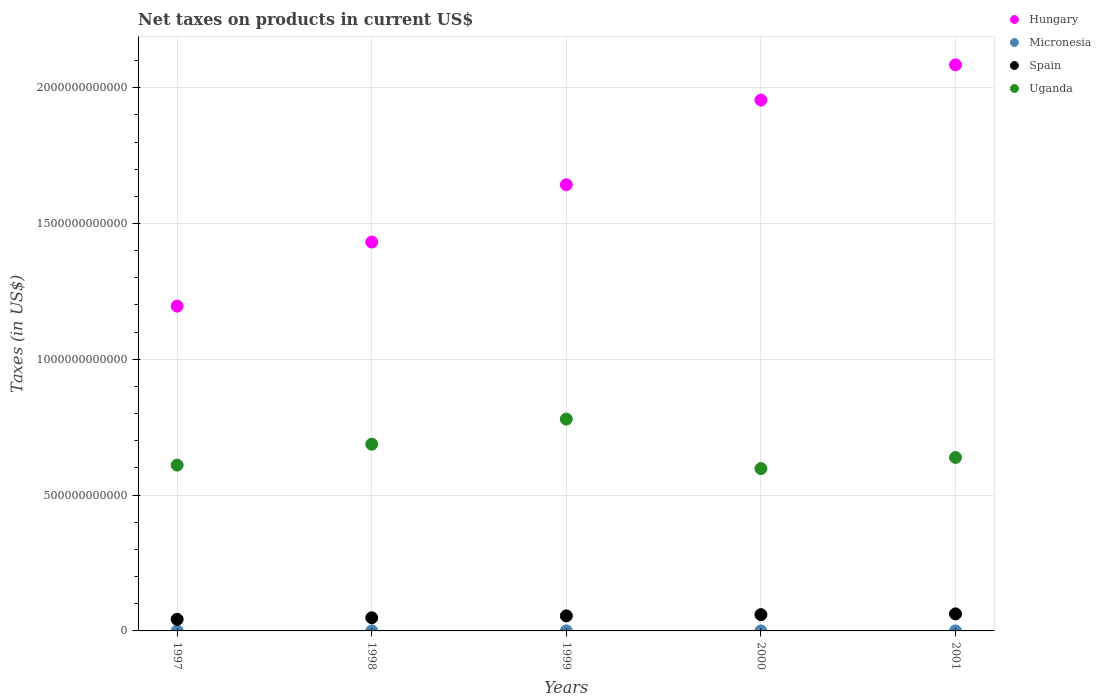How many different coloured dotlines are there?
Offer a very short reply. 4. What is the net taxes on products in Uganda in 1997?
Ensure brevity in your answer.  6.11e+11. Across all years, what is the maximum net taxes on products in Hungary?
Make the answer very short. 2.08e+12. Across all years, what is the minimum net taxes on products in Spain?
Keep it short and to the point. 4.27e+1. What is the total net taxes on products in Spain in the graph?
Give a very brief answer. 2.69e+11. What is the difference between the net taxes on products in Hungary in 1997 and that in 1999?
Keep it short and to the point. -4.47e+11. What is the difference between the net taxes on products in Uganda in 1997 and the net taxes on products in Spain in 2001?
Give a very brief answer. 5.48e+11. What is the average net taxes on products in Spain per year?
Give a very brief answer. 5.38e+1. In the year 1998, what is the difference between the net taxes on products in Uganda and net taxes on products in Spain?
Offer a very short reply. 6.39e+11. What is the ratio of the net taxes on products in Hungary in 1999 to that in 2000?
Make the answer very short. 0.84. Is the net taxes on products in Hungary in 1997 less than that in 1998?
Offer a very short reply. Yes. What is the difference between the highest and the second highest net taxes on products in Uganda?
Provide a succinct answer. 9.24e+1. What is the difference between the highest and the lowest net taxes on products in Micronesia?
Provide a succinct answer. 4.64e+06. Is it the case that in every year, the sum of the net taxes on products in Spain and net taxes on products in Micronesia  is greater than the net taxes on products in Hungary?
Offer a very short reply. No. Is the net taxes on products in Uganda strictly less than the net taxes on products in Hungary over the years?
Provide a succinct answer. Yes. How many dotlines are there?
Your answer should be compact. 4. What is the difference between two consecutive major ticks on the Y-axis?
Offer a very short reply. 5.00e+11. Does the graph contain grids?
Offer a very short reply. Yes. How many legend labels are there?
Your answer should be very brief. 4. What is the title of the graph?
Offer a very short reply. Net taxes on products in current US$. Does "Bulgaria" appear as one of the legend labels in the graph?
Make the answer very short. No. What is the label or title of the X-axis?
Ensure brevity in your answer.  Years. What is the label or title of the Y-axis?
Your response must be concise. Taxes (in US$). What is the Taxes (in US$) of Hungary in 1997?
Offer a terse response. 1.20e+12. What is the Taxes (in US$) of Micronesia in 1997?
Offer a terse response. 1.00e+07. What is the Taxes (in US$) in Spain in 1997?
Make the answer very short. 4.27e+1. What is the Taxes (in US$) in Uganda in 1997?
Your response must be concise. 6.11e+11. What is the Taxes (in US$) in Hungary in 1998?
Provide a succinct answer. 1.43e+12. What is the Taxes (in US$) in Micronesia in 1998?
Your response must be concise. 1.18e+07. What is the Taxes (in US$) of Spain in 1998?
Give a very brief answer. 4.85e+1. What is the Taxes (in US$) in Uganda in 1998?
Provide a succinct answer. 6.87e+11. What is the Taxes (in US$) in Hungary in 1999?
Give a very brief answer. 1.64e+12. What is the Taxes (in US$) of Micronesia in 1999?
Your response must be concise. 1.37e+07. What is the Taxes (in US$) in Spain in 1999?
Ensure brevity in your answer.  5.54e+1. What is the Taxes (in US$) in Uganda in 1999?
Give a very brief answer. 7.80e+11. What is the Taxes (in US$) of Hungary in 2000?
Give a very brief answer. 1.95e+12. What is the Taxes (in US$) in Micronesia in 2000?
Your response must be concise. 1.47e+07. What is the Taxes (in US$) in Spain in 2000?
Provide a succinct answer. 5.99e+1. What is the Taxes (in US$) in Uganda in 2000?
Give a very brief answer. 5.98e+11. What is the Taxes (in US$) in Hungary in 2001?
Offer a very short reply. 2.08e+12. What is the Taxes (in US$) of Micronesia in 2001?
Make the answer very short. 1.35e+07. What is the Taxes (in US$) of Spain in 2001?
Provide a succinct answer. 6.27e+1. What is the Taxes (in US$) of Uganda in 2001?
Your answer should be very brief. 6.39e+11. Across all years, what is the maximum Taxes (in US$) in Hungary?
Provide a short and direct response. 2.08e+12. Across all years, what is the maximum Taxes (in US$) in Micronesia?
Give a very brief answer. 1.47e+07. Across all years, what is the maximum Taxes (in US$) in Spain?
Offer a very short reply. 6.27e+1. Across all years, what is the maximum Taxes (in US$) in Uganda?
Your response must be concise. 7.80e+11. Across all years, what is the minimum Taxes (in US$) in Hungary?
Provide a short and direct response. 1.20e+12. Across all years, what is the minimum Taxes (in US$) of Micronesia?
Make the answer very short. 1.00e+07. Across all years, what is the minimum Taxes (in US$) of Spain?
Give a very brief answer. 4.27e+1. Across all years, what is the minimum Taxes (in US$) of Uganda?
Your response must be concise. 5.98e+11. What is the total Taxes (in US$) in Hungary in the graph?
Keep it short and to the point. 8.31e+12. What is the total Taxes (in US$) of Micronesia in the graph?
Offer a very short reply. 6.37e+07. What is the total Taxes (in US$) in Spain in the graph?
Provide a short and direct response. 2.69e+11. What is the total Taxes (in US$) of Uganda in the graph?
Give a very brief answer. 3.31e+12. What is the difference between the Taxes (in US$) in Hungary in 1997 and that in 1998?
Give a very brief answer. -2.36e+11. What is the difference between the Taxes (in US$) of Micronesia in 1997 and that in 1998?
Keep it short and to the point. -1.83e+06. What is the difference between the Taxes (in US$) in Spain in 1997 and that in 1998?
Your answer should be very brief. -5.72e+09. What is the difference between the Taxes (in US$) of Uganda in 1997 and that in 1998?
Offer a very short reply. -7.69e+1. What is the difference between the Taxes (in US$) in Hungary in 1997 and that in 1999?
Your answer should be compact. -4.47e+11. What is the difference between the Taxes (in US$) of Micronesia in 1997 and that in 1999?
Your answer should be very brief. -3.65e+06. What is the difference between the Taxes (in US$) of Spain in 1997 and that in 1999?
Provide a short and direct response. -1.26e+1. What is the difference between the Taxes (in US$) of Uganda in 1997 and that in 1999?
Your response must be concise. -1.69e+11. What is the difference between the Taxes (in US$) in Hungary in 1997 and that in 2000?
Offer a terse response. -7.58e+11. What is the difference between the Taxes (in US$) in Micronesia in 1997 and that in 2000?
Provide a short and direct response. -4.64e+06. What is the difference between the Taxes (in US$) in Spain in 1997 and that in 2000?
Make the answer very short. -1.72e+1. What is the difference between the Taxes (in US$) in Uganda in 1997 and that in 2000?
Your answer should be very brief. 1.29e+1. What is the difference between the Taxes (in US$) in Hungary in 1997 and that in 2001?
Provide a short and direct response. -8.88e+11. What is the difference between the Taxes (in US$) of Micronesia in 1997 and that in 2001?
Offer a terse response. -3.47e+06. What is the difference between the Taxes (in US$) of Spain in 1997 and that in 2001?
Provide a short and direct response. -2.00e+1. What is the difference between the Taxes (in US$) of Uganda in 1997 and that in 2001?
Offer a terse response. -2.80e+1. What is the difference between the Taxes (in US$) in Hungary in 1998 and that in 1999?
Your answer should be very brief. -2.11e+11. What is the difference between the Taxes (in US$) in Micronesia in 1998 and that in 1999?
Your answer should be compact. -1.82e+06. What is the difference between the Taxes (in US$) in Spain in 1998 and that in 1999?
Your answer should be compact. -6.91e+09. What is the difference between the Taxes (in US$) of Uganda in 1998 and that in 1999?
Provide a short and direct response. -9.24e+1. What is the difference between the Taxes (in US$) of Hungary in 1998 and that in 2000?
Provide a short and direct response. -5.22e+11. What is the difference between the Taxes (in US$) in Micronesia in 1998 and that in 2000?
Keep it short and to the point. -2.81e+06. What is the difference between the Taxes (in US$) of Spain in 1998 and that in 2000?
Provide a short and direct response. -1.15e+1. What is the difference between the Taxes (in US$) in Uganda in 1998 and that in 2000?
Your answer should be compact. 8.98e+1. What is the difference between the Taxes (in US$) of Hungary in 1998 and that in 2001?
Your answer should be compact. -6.52e+11. What is the difference between the Taxes (in US$) in Micronesia in 1998 and that in 2001?
Make the answer very short. -1.64e+06. What is the difference between the Taxes (in US$) in Spain in 1998 and that in 2001?
Ensure brevity in your answer.  -1.42e+1. What is the difference between the Taxes (in US$) in Uganda in 1998 and that in 2001?
Provide a succinct answer. 4.89e+1. What is the difference between the Taxes (in US$) of Hungary in 1999 and that in 2000?
Provide a succinct answer. -3.12e+11. What is the difference between the Taxes (in US$) of Micronesia in 1999 and that in 2000?
Offer a terse response. -9.94e+05. What is the difference between the Taxes (in US$) of Spain in 1999 and that in 2000?
Provide a short and direct response. -4.55e+09. What is the difference between the Taxes (in US$) of Uganda in 1999 and that in 2000?
Your response must be concise. 1.82e+11. What is the difference between the Taxes (in US$) in Hungary in 1999 and that in 2001?
Your response must be concise. -4.41e+11. What is the difference between the Taxes (in US$) in Micronesia in 1999 and that in 2001?
Your response must be concise. 1.83e+05. What is the difference between the Taxes (in US$) of Spain in 1999 and that in 2001?
Your answer should be compact. -7.33e+09. What is the difference between the Taxes (in US$) of Uganda in 1999 and that in 2001?
Offer a very short reply. 1.41e+11. What is the difference between the Taxes (in US$) of Hungary in 2000 and that in 2001?
Ensure brevity in your answer.  -1.30e+11. What is the difference between the Taxes (in US$) of Micronesia in 2000 and that in 2001?
Make the answer very short. 1.18e+06. What is the difference between the Taxes (in US$) of Spain in 2000 and that in 2001?
Your answer should be compact. -2.78e+09. What is the difference between the Taxes (in US$) of Uganda in 2000 and that in 2001?
Provide a short and direct response. -4.09e+1. What is the difference between the Taxes (in US$) of Hungary in 1997 and the Taxes (in US$) of Micronesia in 1998?
Make the answer very short. 1.20e+12. What is the difference between the Taxes (in US$) in Hungary in 1997 and the Taxes (in US$) in Spain in 1998?
Your response must be concise. 1.15e+12. What is the difference between the Taxes (in US$) of Hungary in 1997 and the Taxes (in US$) of Uganda in 1998?
Provide a succinct answer. 5.08e+11. What is the difference between the Taxes (in US$) of Micronesia in 1997 and the Taxes (in US$) of Spain in 1998?
Your answer should be compact. -4.85e+1. What is the difference between the Taxes (in US$) in Micronesia in 1997 and the Taxes (in US$) in Uganda in 1998?
Keep it short and to the point. -6.87e+11. What is the difference between the Taxes (in US$) in Spain in 1997 and the Taxes (in US$) in Uganda in 1998?
Offer a very short reply. -6.45e+11. What is the difference between the Taxes (in US$) in Hungary in 1997 and the Taxes (in US$) in Micronesia in 1999?
Your answer should be compact. 1.20e+12. What is the difference between the Taxes (in US$) of Hungary in 1997 and the Taxes (in US$) of Spain in 1999?
Keep it short and to the point. 1.14e+12. What is the difference between the Taxes (in US$) in Hungary in 1997 and the Taxes (in US$) in Uganda in 1999?
Your answer should be compact. 4.16e+11. What is the difference between the Taxes (in US$) in Micronesia in 1997 and the Taxes (in US$) in Spain in 1999?
Ensure brevity in your answer.  -5.54e+1. What is the difference between the Taxes (in US$) of Micronesia in 1997 and the Taxes (in US$) of Uganda in 1999?
Make the answer very short. -7.80e+11. What is the difference between the Taxes (in US$) of Spain in 1997 and the Taxes (in US$) of Uganda in 1999?
Provide a short and direct response. -7.37e+11. What is the difference between the Taxes (in US$) in Hungary in 1997 and the Taxes (in US$) in Micronesia in 2000?
Keep it short and to the point. 1.20e+12. What is the difference between the Taxes (in US$) of Hungary in 1997 and the Taxes (in US$) of Spain in 2000?
Provide a succinct answer. 1.14e+12. What is the difference between the Taxes (in US$) of Hungary in 1997 and the Taxes (in US$) of Uganda in 2000?
Keep it short and to the point. 5.98e+11. What is the difference between the Taxes (in US$) of Micronesia in 1997 and the Taxes (in US$) of Spain in 2000?
Your answer should be very brief. -5.99e+1. What is the difference between the Taxes (in US$) of Micronesia in 1997 and the Taxes (in US$) of Uganda in 2000?
Provide a short and direct response. -5.98e+11. What is the difference between the Taxes (in US$) in Spain in 1997 and the Taxes (in US$) in Uganda in 2000?
Make the answer very short. -5.55e+11. What is the difference between the Taxes (in US$) in Hungary in 1997 and the Taxes (in US$) in Micronesia in 2001?
Your answer should be very brief. 1.20e+12. What is the difference between the Taxes (in US$) of Hungary in 1997 and the Taxes (in US$) of Spain in 2001?
Make the answer very short. 1.13e+12. What is the difference between the Taxes (in US$) of Hungary in 1997 and the Taxes (in US$) of Uganda in 2001?
Make the answer very short. 5.57e+11. What is the difference between the Taxes (in US$) of Micronesia in 1997 and the Taxes (in US$) of Spain in 2001?
Offer a terse response. -6.27e+1. What is the difference between the Taxes (in US$) in Micronesia in 1997 and the Taxes (in US$) in Uganda in 2001?
Keep it short and to the point. -6.39e+11. What is the difference between the Taxes (in US$) in Spain in 1997 and the Taxes (in US$) in Uganda in 2001?
Your response must be concise. -5.96e+11. What is the difference between the Taxes (in US$) in Hungary in 1998 and the Taxes (in US$) in Micronesia in 1999?
Offer a very short reply. 1.43e+12. What is the difference between the Taxes (in US$) of Hungary in 1998 and the Taxes (in US$) of Spain in 1999?
Offer a very short reply. 1.38e+12. What is the difference between the Taxes (in US$) of Hungary in 1998 and the Taxes (in US$) of Uganda in 1999?
Your answer should be compact. 6.52e+11. What is the difference between the Taxes (in US$) of Micronesia in 1998 and the Taxes (in US$) of Spain in 1999?
Your answer should be compact. -5.54e+1. What is the difference between the Taxes (in US$) in Micronesia in 1998 and the Taxes (in US$) in Uganda in 1999?
Your answer should be very brief. -7.80e+11. What is the difference between the Taxes (in US$) of Spain in 1998 and the Taxes (in US$) of Uganda in 1999?
Keep it short and to the point. -7.31e+11. What is the difference between the Taxes (in US$) in Hungary in 1998 and the Taxes (in US$) in Micronesia in 2000?
Provide a succinct answer. 1.43e+12. What is the difference between the Taxes (in US$) in Hungary in 1998 and the Taxes (in US$) in Spain in 2000?
Offer a very short reply. 1.37e+12. What is the difference between the Taxes (in US$) of Hungary in 1998 and the Taxes (in US$) of Uganda in 2000?
Provide a succinct answer. 8.34e+11. What is the difference between the Taxes (in US$) of Micronesia in 1998 and the Taxes (in US$) of Spain in 2000?
Your answer should be very brief. -5.99e+1. What is the difference between the Taxes (in US$) of Micronesia in 1998 and the Taxes (in US$) of Uganda in 2000?
Offer a very short reply. -5.98e+11. What is the difference between the Taxes (in US$) of Spain in 1998 and the Taxes (in US$) of Uganda in 2000?
Make the answer very short. -5.49e+11. What is the difference between the Taxes (in US$) of Hungary in 1998 and the Taxes (in US$) of Micronesia in 2001?
Offer a terse response. 1.43e+12. What is the difference between the Taxes (in US$) in Hungary in 1998 and the Taxes (in US$) in Spain in 2001?
Keep it short and to the point. 1.37e+12. What is the difference between the Taxes (in US$) in Hungary in 1998 and the Taxes (in US$) in Uganda in 2001?
Your response must be concise. 7.93e+11. What is the difference between the Taxes (in US$) in Micronesia in 1998 and the Taxes (in US$) in Spain in 2001?
Make the answer very short. -6.27e+1. What is the difference between the Taxes (in US$) of Micronesia in 1998 and the Taxes (in US$) of Uganda in 2001?
Offer a terse response. -6.39e+11. What is the difference between the Taxes (in US$) of Spain in 1998 and the Taxes (in US$) of Uganda in 2001?
Offer a terse response. -5.90e+11. What is the difference between the Taxes (in US$) in Hungary in 1999 and the Taxes (in US$) in Micronesia in 2000?
Offer a terse response. 1.64e+12. What is the difference between the Taxes (in US$) of Hungary in 1999 and the Taxes (in US$) of Spain in 2000?
Offer a very short reply. 1.58e+12. What is the difference between the Taxes (in US$) of Hungary in 1999 and the Taxes (in US$) of Uganda in 2000?
Make the answer very short. 1.04e+12. What is the difference between the Taxes (in US$) in Micronesia in 1999 and the Taxes (in US$) in Spain in 2000?
Provide a short and direct response. -5.99e+1. What is the difference between the Taxes (in US$) in Micronesia in 1999 and the Taxes (in US$) in Uganda in 2000?
Ensure brevity in your answer.  -5.98e+11. What is the difference between the Taxes (in US$) in Spain in 1999 and the Taxes (in US$) in Uganda in 2000?
Provide a succinct answer. -5.42e+11. What is the difference between the Taxes (in US$) in Hungary in 1999 and the Taxes (in US$) in Micronesia in 2001?
Your answer should be compact. 1.64e+12. What is the difference between the Taxes (in US$) in Hungary in 1999 and the Taxes (in US$) in Spain in 2001?
Your answer should be compact. 1.58e+12. What is the difference between the Taxes (in US$) in Hungary in 1999 and the Taxes (in US$) in Uganda in 2001?
Make the answer very short. 1.00e+12. What is the difference between the Taxes (in US$) of Micronesia in 1999 and the Taxes (in US$) of Spain in 2001?
Your answer should be compact. -6.27e+1. What is the difference between the Taxes (in US$) of Micronesia in 1999 and the Taxes (in US$) of Uganda in 2001?
Provide a succinct answer. -6.39e+11. What is the difference between the Taxes (in US$) in Spain in 1999 and the Taxes (in US$) in Uganda in 2001?
Ensure brevity in your answer.  -5.83e+11. What is the difference between the Taxes (in US$) of Hungary in 2000 and the Taxes (in US$) of Micronesia in 2001?
Offer a terse response. 1.95e+12. What is the difference between the Taxes (in US$) of Hungary in 2000 and the Taxes (in US$) of Spain in 2001?
Keep it short and to the point. 1.89e+12. What is the difference between the Taxes (in US$) in Hungary in 2000 and the Taxes (in US$) in Uganda in 2001?
Ensure brevity in your answer.  1.32e+12. What is the difference between the Taxes (in US$) in Micronesia in 2000 and the Taxes (in US$) in Spain in 2001?
Offer a very short reply. -6.27e+1. What is the difference between the Taxes (in US$) of Micronesia in 2000 and the Taxes (in US$) of Uganda in 2001?
Keep it short and to the point. -6.39e+11. What is the difference between the Taxes (in US$) in Spain in 2000 and the Taxes (in US$) in Uganda in 2001?
Provide a short and direct response. -5.79e+11. What is the average Taxes (in US$) in Hungary per year?
Offer a terse response. 1.66e+12. What is the average Taxes (in US$) of Micronesia per year?
Provide a short and direct response. 1.27e+07. What is the average Taxes (in US$) in Spain per year?
Offer a very short reply. 5.38e+1. What is the average Taxes (in US$) of Uganda per year?
Provide a succinct answer. 6.63e+11. In the year 1997, what is the difference between the Taxes (in US$) of Hungary and Taxes (in US$) of Micronesia?
Your response must be concise. 1.20e+12. In the year 1997, what is the difference between the Taxes (in US$) in Hungary and Taxes (in US$) in Spain?
Provide a succinct answer. 1.15e+12. In the year 1997, what is the difference between the Taxes (in US$) of Hungary and Taxes (in US$) of Uganda?
Provide a short and direct response. 5.85e+11. In the year 1997, what is the difference between the Taxes (in US$) in Micronesia and Taxes (in US$) in Spain?
Offer a terse response. -4.27e+1. In the year 1997, what is the difference between the Taxes (in US$) of Micronesia and Taxes (in US$) of Uganda?
Your answer should be compact. -6.11e+11. In the year 1997, what is the difference between the Taxes (in US$) of Spain and Taxes (in US$) of Uganda?
Your answer should be very brief. -5.68e+11. In the year 1998, what is the difference between the Taxes (in US$) in Hungary and Taxes (in US$) in Micronesia?
Your answer should be very brief. 1.43e+12. In the year 1998, what is the difference between the Taxes (in US$) of Hungary and Taxes (in US$) of Spain?
Provide a succinct answer. 1.38e+12. In the year 1998, what is the difference between the Taxes (in US$) of Hungary and Taxes (in US$) of Uganda?
Your answer should be very brief. 7.44e+11. In the year 1998, what is the difference between the Taxes (in US$) of Micronesia and Taxes (in US$) of Spain?
Provide a short and direct response. -4.85e+1. In the year 1998, what is the difference between the Taxes (in US$) of Micronesia and Taxes (in US$) of Uganda?
Your answer should be very brief. -6.87e+11. In the year 1998, what is the difference between the Taxes (in US$) of Spain and Taxes (in US$) of Uganda?
Provide a short and direct response. -6.39e+11. In the year 1999, what is the difference between the Taxes (in US$) in Hungary and Taxes (in US$) in Micronesia?
Your answer should be compact. 1.64e+12. In the year 1999, what is the difference between the Taxes (in US$) in Hungary and Taxes (in US$) in Spain?
Provide a succinct answer. 1.59e+12. In the year 1999, what is the difference between the Taxes (in US$) of Hungary and Taxes (in US$) of Uganda?
Keep it short and to the point. 8.63e+11. In the year 1999, what is the difference between the Taxes (in US$) in Micronesia and Taxes (in US$) in Spain?
Offer a very short reply. -5.54e+1. In the year 1999, what is the difference between the Taxes (in US$) in Micronesia and Taxes (in US$) in Uganda?
Make the answer very short. -7.80e+11. In the year 1999, what is the difference between the Taxes (in US$) in Spain and Taxes (in US$) in Uganda?
Provide a succinct answer. -7.24e+11. In the year 2000, what is the difference between the Taxes (in US$) of Hungary and Taxes (in US$) of Micronesia?
Ensure brevity in your answer.  1.95e+12. In the year 2000, what is the difference between the Taxes (in US$) of Hungary and Taxes (in US$) of Spain?
Offer a terse response. 1.89e+12. In the year 2000, what is the difference between the Taxes (in US$) in Hungary and Taxes (in US$) in Uganda?
Ensure brevity in your answer.  1.36e+12. In the year 2000, what is the difference between the Taxes (in US$) in Micronesia and Taxes (in US$) in Spain?
Give a very brief answer. -5.99e+1. In the year 2000, what is the difference between the Taxes (in US$) in Micronesia and Taxes (in US$) in Uganda?
Offer a very short reply. -5.98e+11. In the year 2000, what is the difference between the Taxes (in US$) of Spain and Taxes (in US$) of Uganda?
Your response must be concise. -5.38e+11. In the year 2001, what is the difference between the Taxes (in US$) of Hungary and Taxes (in US$) of Micronesia?
Make the answer very short. 2.08e+12. In the year 2001, what is the difference between the Taxes (in US$) of Hungary and Taxes (in US$) of Spain?
Offer a terse response. 2.02e+12. In the year 2001, what is the difference between the Taxes (in US$) in Hungary and Taxes (in US$) in Uganda?
Your answer should be very brief. 1.45e+12. In the year 2001, what is the difference between the Taxes (in US$) in Micronesia and Taxes (in US$) in Spain?
Give a very brief answer. -6.27e+1. In the year 2001, what is the difference between the Taxes (in US$) of Micronesia and Taxes (in US$) of Uganda?
Ensure brevity in your answer.  -6.39e+11. In the year 2001, what is the difference between the Taxes (in US$) in Spain and Taxes (in US$) in Uganda?
Your answer should be compact. -5.76e+11. What is the ratio of the Taxes (in US$) in Hungary in 1997 to that in 1998?
Offer a terse response. 0.84. What is the ratio of the Taxes (in US$) of Micronesia in 1997 to that in 1998?
Ensure brevity in your answer.  0.85. What is the ratio of the Taxes (in US$) of Spain in 1997 to that in 1998?
Your answer should be compact. 0.88. What is the ratio of the Taxes (in US$) in Uganda in 1997 to that in 1998?
Make the answer very short. 0.89. What is the ratio of the Taxes (in US$) of Hungary in 1997 to that in 1999?
Offer a very short reply. 0.73. What is the ratio of the Taxes (in US$) in Micronesia in 1997 to that in 1999?
Provide a short and direct response. 0.73. What is the ratio of the Taxes (in US$) in Spain in 1997 to that in 1999?
Make the answer very short. 0.77. What is the ratio of the Taxes (in US$) in Uganda in 1997 to that in 1999?
Your answer should be very brief. 0.78. What is the ratio of the Taxes (in US$) in Hungary in 1997 to that in 2000?
Offer a terse response. 0.61. What is the ratio of the Taxes (in US$) of Micronesia in 1997 to that in 2000?
Provide a short and direct response. 0.68. What is the ratio of the Taxes (in US$) in Spain in 1997 to that in 2000?
Make the answer very short. 0.71. What is the ratio of the Taxes (in US$) in Uganda in 1997 to that in 2000?
Your response must be concise. 1.02. What is the ratio of the Taxes (in US$) of Hungary in 1997 to that in 2001?
Keep it short and to the point. 0.57. What is the ratio of the Taxes (in US$) of Micronesia in 1997 to that in 2001?
Make the answer very short. 0.74. What is the ratio of the Taxes (in US$) of Spain in 1997 to that in 2001?
Provide a succinct answer. 0.68. What is the ratio of the Taxes (in US$) of Uganda in 1997 to that in 2001?
Give a very brief answer. 0.96. What is the ratio of the Taxes (in US$) of Hungary in 1998 to that in 1999?
Make the answer very short. 0.87. What is the ratio of the Taxes (in US$) in Micronesia in 1998 to that in 1999?
Keep it short and to the point. 0.87. What is the ratio of the Taxes (in US$) in Spain in 1998 to that in 1999?
Your answer should be compact. 0.88. What is the ratio of the Taxes (in US$) of Uganda in 1998 to that in 1999?
Your answer should be compact. 0.88. What is the ratio of the Taxes (in US$) in Hungary in 1998 to that in 2000?
Offer a very short reply. 0.73. What is the ratio of the Taxes (in US$) of Micronesia in 1998 to that in 2000?
Offer a terse response. 0.81. What is the ratio of the Taxes (in US$) in Spain in 1998 to that in 2000?
Give a very brief answer. 0.81. What is the ratio of the Taxes (in US$) of Uganda in 1998 to that in 2000?
Offer a terse response. 1.15. What is the ratio of the Taxes (in US$) in Hungary in 1998 to that in 2001?
Your answer should be compact. 0.69. What is the ratio of the Taxes (in US$) of Micronesia in 1998 to that in 2001?
Offer a very short reply. 0.88. What is the ratio of the Taxes (in US$) in Spain in 1998 to that in 2001?
Your response must be concise. 0.77. What is the ratio of the Taxes (in US$) of Uganda in 1998 to that in 2001?
Provide a short and direct response. 1.08. What is the ratio of the Taxes (in US$) in Hungary in 1999 to that in 2000?
Provide a short and direct response. 0.84. What is the ratio of the Taxes (in US$) in Micronesia in 1999 to that in 2000?
Your answer should be compact. 0.93. What is the ratio of the Taxes (in US$) of Spain in 1999 to that in 2000?
Your response must be concise. 0.92. What is the ratio of the Taxes (in US$) in Uganda in 1999 to that in 2000?
Provide a succinct answer. 1.3. What is the ratio of the Taxes (in US$) of Hungary in 1999 to that in 2001?
Keep it short and to the point. 0.79. What is the ratio of the Taxes (in US$) in Micronesia in 1999 to that in 2001?
Your answer should be very brief. 1.01. What is the ratio of the Taxes (in US$) of Spain in 1999 to that in 2001?
Your answer should be compact. 0.88. What is the ratio of the Taxes (in US$) in Uganda in 1999 to that in 2001?
Provide a succinct answer. 1.22. What is the ratio of the Taxes (in US$) of Hungary in 2000 to that in 2001?
Make the answer very short. 0.94. What is the ratio of the Taxes (in US$) of Micronesia in 2000 to that in 2001?
Your answer should be compact. 1.09. What is the ratio of the Taxes (in US$) of Spain in 2000 to that in 2001?
Provide a short and direct response. 0.96. What is the ratio of the Taxes (in US$) of Uganda in 2000 to that in 2001?
Provide a succinct answer. 0.94. What is the difference between the highest and the second highest Taxes (in US$) of Hungary?
Keep it short and to the point. 1.30e+11. What is the difference between the highest and the second highest Taxes (in US$) of Micronesia?
Your answer should be compact. 9.94e+05. What is the difference between the highest and the second highest Taxes (in US$) in Spain?
Your answer should be compact. 2.78e+09. What is the difference between the highest and the second highest Taxes (in US$) of Uganda?
Offer a very short reply. 9.24e+1. What is the difference between the highest and the lowest Taxes (in US$) in Hungary?
Make the answer very short. 8.88e+11. What is the difference between the highest and the lowest Taxes (in US$) in Micronesia?
Your answer should be compact. 4.64e+06. What is the difference between the highest and the lowest Taxes (in US$) in Spain?
Your response must be concise. 2.00e+1. What is the difference between the highest and the lowest Taxes (in US$) of Uganda?
Give a very brief answer. 1.82e+11. 